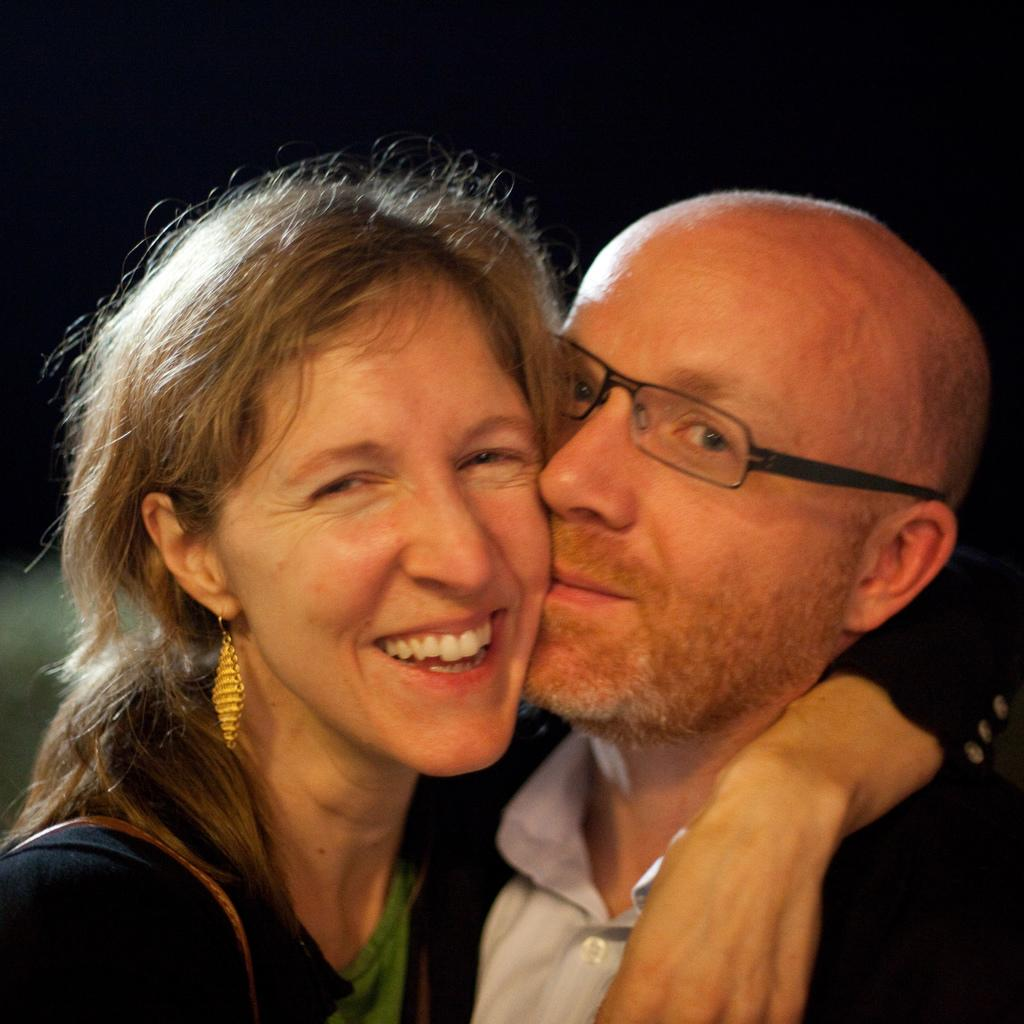What is the overall color scheme of the image? The background of the image is dark. Can you describe the people in the image? There is a man and a woman in the image. What expressions do the man and woman have? Both the man and the woman have smiling faces. What type of car can be seen in the background of the image? There is no car present in the image; it only features a man and a woman with smiling faces against a dark background. 